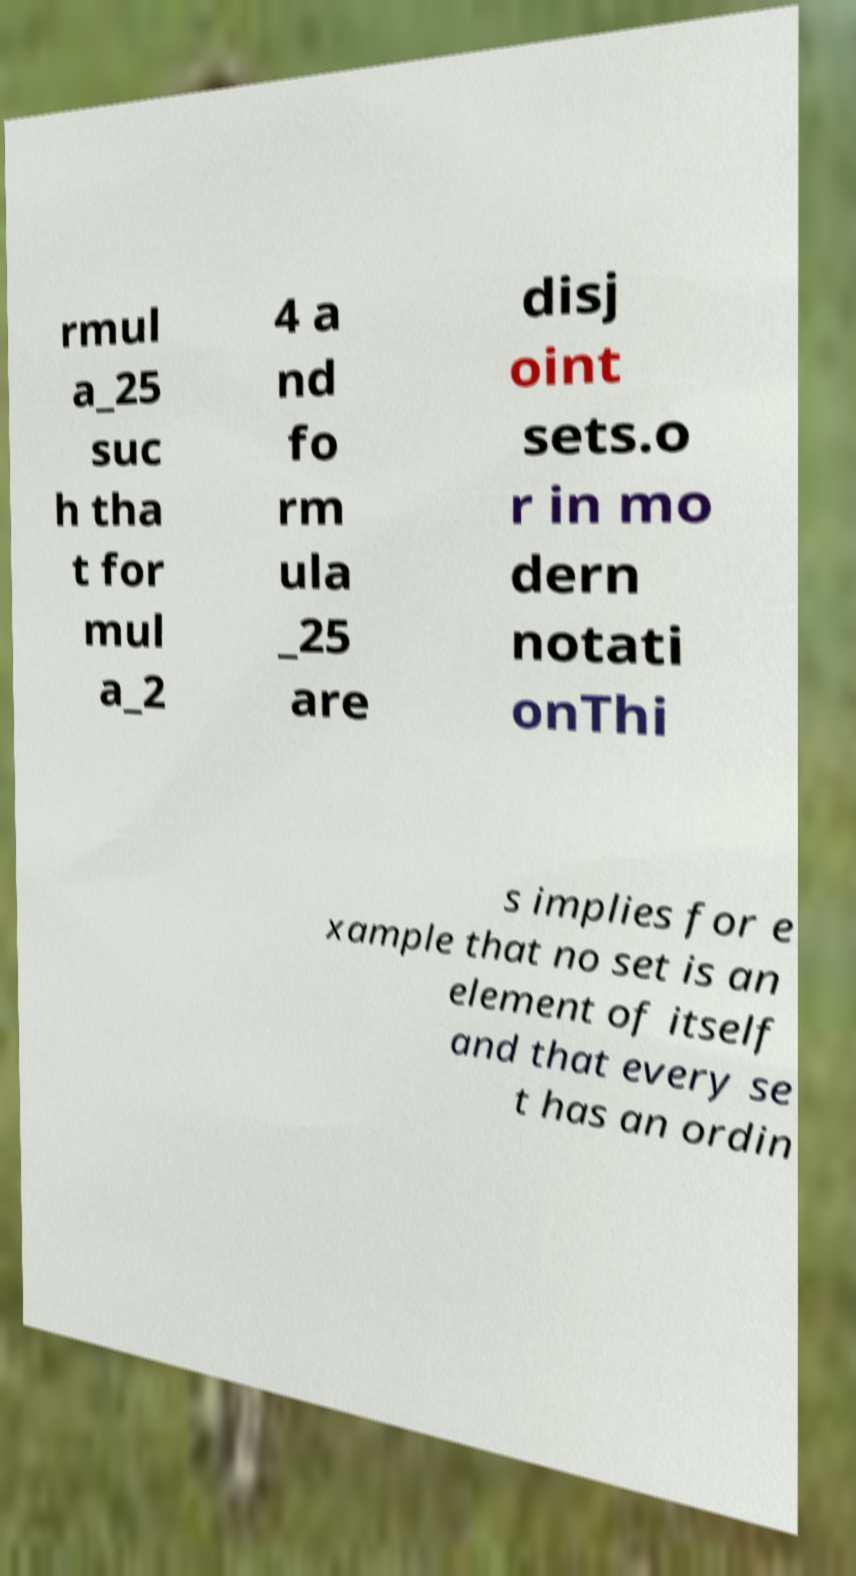What messages or text are displayed in this image? I need them in a readable, typed format. rmul a_25 suc h tha t for mul a_2 4 a nd fo rm ula _25 are disj oint sets.o r in mo dern notati onThi s implies for e xample that no set is an element of itself and that every se t has an ordin 